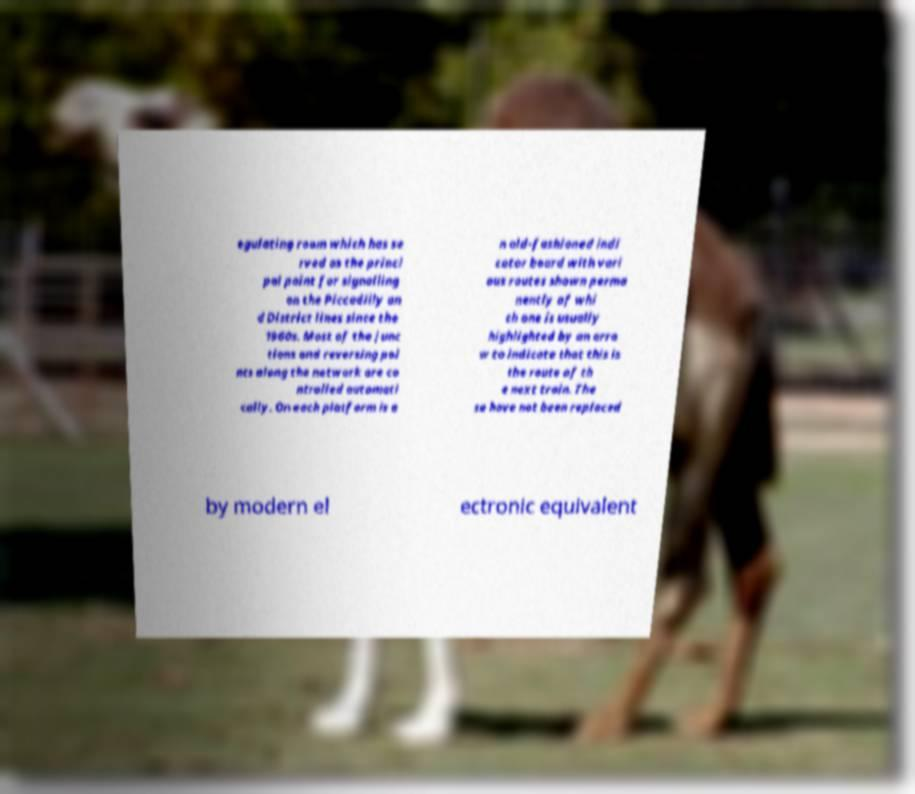Could you assist in decoding the text presented in this image and type it out clearly? egulating room which has se rved as the princi pal point for signalling on the Piccadilly an d District lines since the 1960s. Most of the junc tions and reversing poi nts along the network are co ntrolled automati cally. On each platform is a n old-fashioned indi cator board with vari ous routes shown perma nently of whi ch one is usually highlighted by an arro w to indicate that this is the route of th e next train. The se have not been replaced by modern el ectronic equivalent 